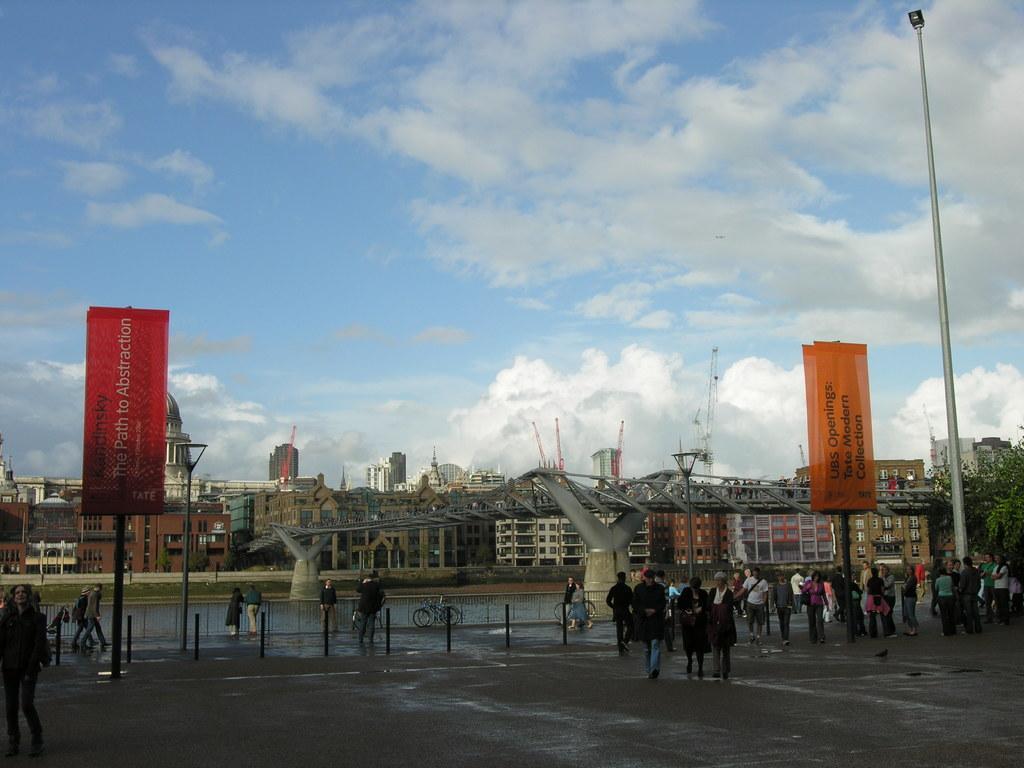How would you summarize this image in a sentence or two? In this picture there are buildings and trees and cranes and there are poles and there are boards on the poles and there is text on the boards. In the foreground there are group of people walking on the road and there are two persons at the railing and there are bicycles. At the top there is sky and there are clouds. At the bottom there is water and there is a road. In the middle of the image there is a bridge. 